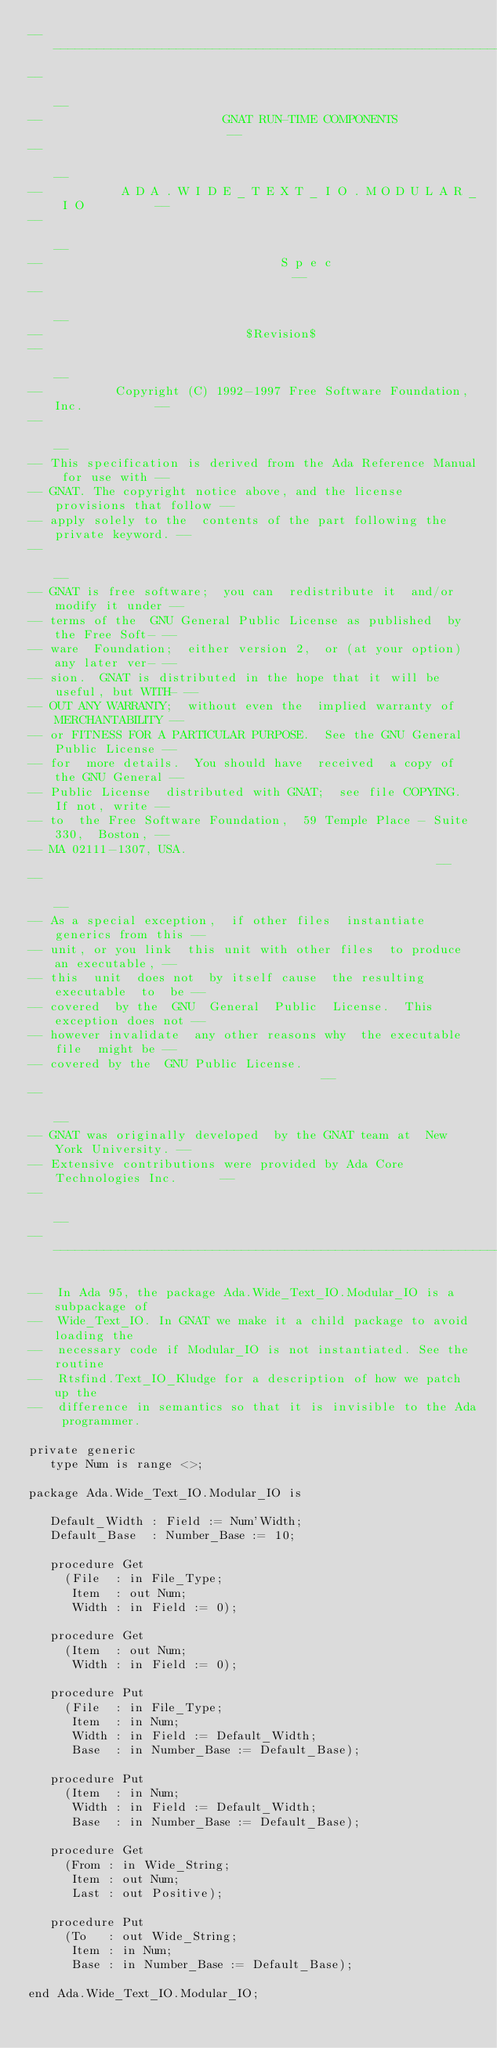Convert code to text. <code><loc_0><loc_0><loc_500><loc_500><_Ada_>------------------------------------------------------------------------------
--                                                                          --
--                         GNAT RUN-TIME COMPONENTS                         --
--                                                                          --
--           A D A . W I D E _ T E X T _ I O . M O D U L A R _ I O          --
--                                                                          --
--                                 S p e c                                  --
--                                                                          --
--                            $Revision$
--                                                                          --
--          Copyright (C) 1992-1997 Free Software Foundation, Inc.          --
--                                                                          --
-- This specification is derived from the Ada Reference Manual for use with --
-- GNAT. The copyright notice above, and the license provisions that follow --
-- apply solely to the  contents of the part following the private keyword. --
--                                                                          --
-- GNAT is free software;  you can  redistribute it  and/or modify it under --
-- terms of the  GNU General Public License as published  by the Free Soft- --
-- ware  Foundation;  either version 2,  or (at your option) any later ver- --
-- sion.  GNAT is distributed in the hope that it will be useful, but WITH- --
-- OUT ANY WARRANTY;  without even the  implied warranty of MERCHANTABILITY --
-- or FITNESS FOR A PARTICULAR PURPOSE.  See the GNU General Public License --
-- for  more details.  You should have  received  a copy of the GNU General --
-- Public License  distributed with GNAT;  see file COPYING.  If not, write --
-- to  the Free Software Foundation,  59 Temple Place - Suite 330,  Boston, --
-- MA 02111-1307, USA.                                                      --
--                                                                          --
-- As a special exception,  if other files  instantiate  generics from this --
-- unit, or you link  this unit with other files  to produce an executable, --
-- this  unit  does not  by itself cause  the resulting  executable  to  be --
-- covered  by the  GNU  General  Public  License.  This exception does not --
-- however invalidate  any other reasons why  the executable file  might be --
-- covered by the  GNU Public License.                                      --
--                                                                          --
-- GNAT was originally developed  by the GNAT team at  New York University. --
-- Extensive contributions were provided by Ada Core Technologies Inc.      --
--                                                                          --
------------------------------------------------------------------------------

--  In Ada 95, the package Ada.Wide_Text_IO.Modular_IO is a subpackage of
--  Wide_Text_IO. In GNAT we make it a child package to avoid loading the
--  necessary code if Modular_IO is not instantiated. See the routine
--  Rtsfind.Text_IO_Kludge for a description of how we patch up the
--  difference in semantics so that it is invisible to the Ada programmer.

private generic
   type Num is range <>;

package Ada.Wide_Text_IO.Modular_IO is

   Default_Width : Field := Num'Width;
   Default_Base  : Number_Base := 10;

   procedure Get
     (File  : in File_Type;
      Item  : out Num;
      Width : in Field := 0);

   procedure Get
     (Item  : out Num;
      Width : in Field := 0);

   procedure Put
     (File  : in File_Type;
      Item  : in Num;
      Width : in Field := Default_Width;
      Base  : in Number_Base := Default_Base);

   procedure Put
     (Item  : in Num;
      Width : in Field := Default_Width;
      Base  : in Number_Base := Default_Base);

   procedure Get
     (From : in Wide_String;
      Item : out Num;
      Last : out Positive);

   procedure Put
     (To   : out Wide_String;
      Item : in Num;
      Base : in Number_Base := Default_Base);

end Ada.Wide_Text_IO.Modular_IO;
</code> 